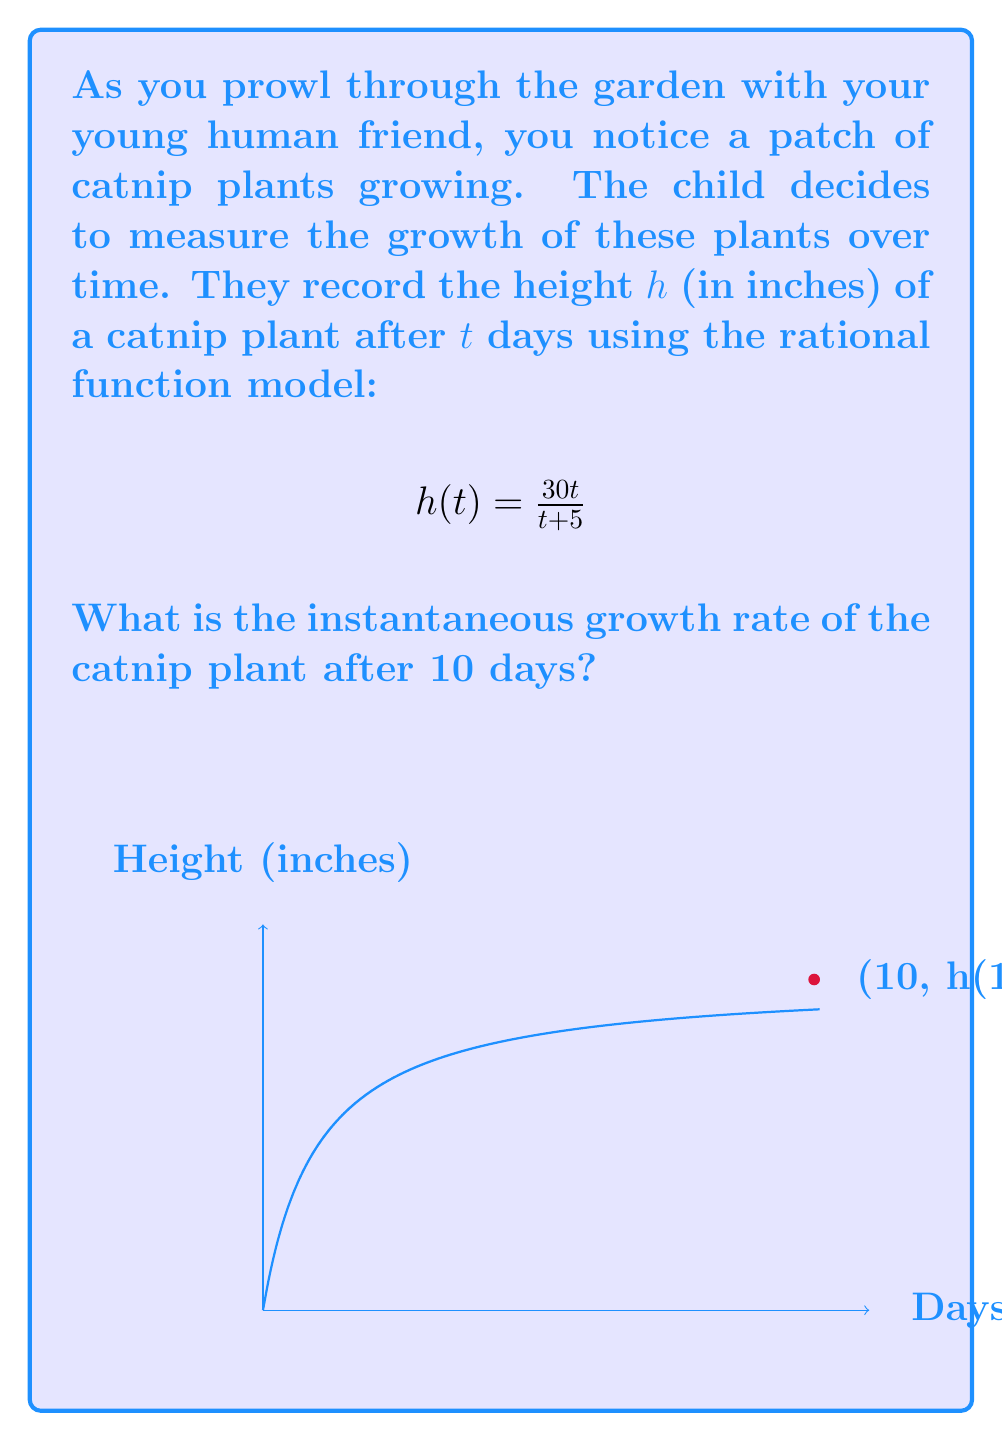Can you solve this math problem? To find the instantaneous growth rate after 10 days, we need to calculate the derivative of the function $h(t)$ and evaluate it at $t = 10$. Let's follow these steps:

1) First, we need to find $h'(t)$ using the quotient rule:
   $$h'(t) = \frac{(t+5)(30) - 30t(1)}{(t+5)^2}$$

2) Simplify the numerator:
   $$h'(t) = \frac{30t + 150 - 30t}{(t+5)^2} = \frac{150}{(t+5)^2}$$

3) Now we have the general formula for the instantaneous growth rate:
   $$h'(t) = \frac{150}{(t+5)^2}$$

4) To find the growth rate after 10 days, we substitute $t = 10$:
   $$h'(10) = \frac{150}{(10+5)^2} = \frac{150}{15^2} = \frac{150}{225} = \frac{2}{3}$$

5) Therefore, the instantaneous growth rate after 10 days is $\frac{2}{3}$ inches per day.
Answer: $\frac{2}{3}$ inches/day 